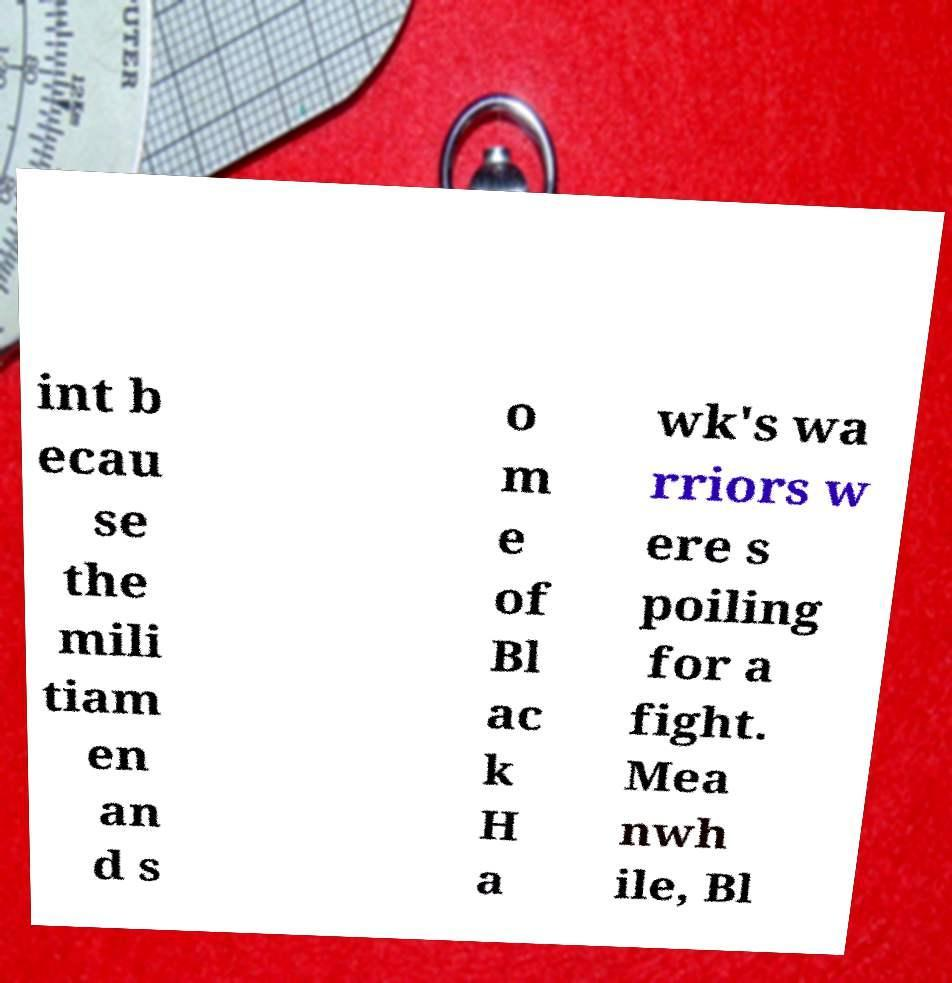For documentation purposes, I need the text within this image transcribed. Could you provide that? int b ecau se the mili tiam en an d s o m e of Bl ac k H a wk's wa rriors w ere s poiling for a fight. Mea nwh ile, Bl 